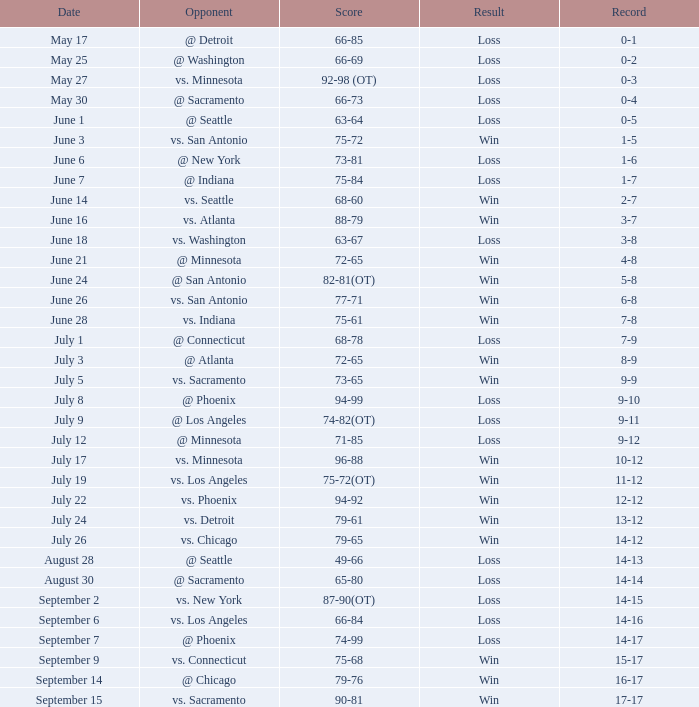What is the Record on July 12? 9-12. 